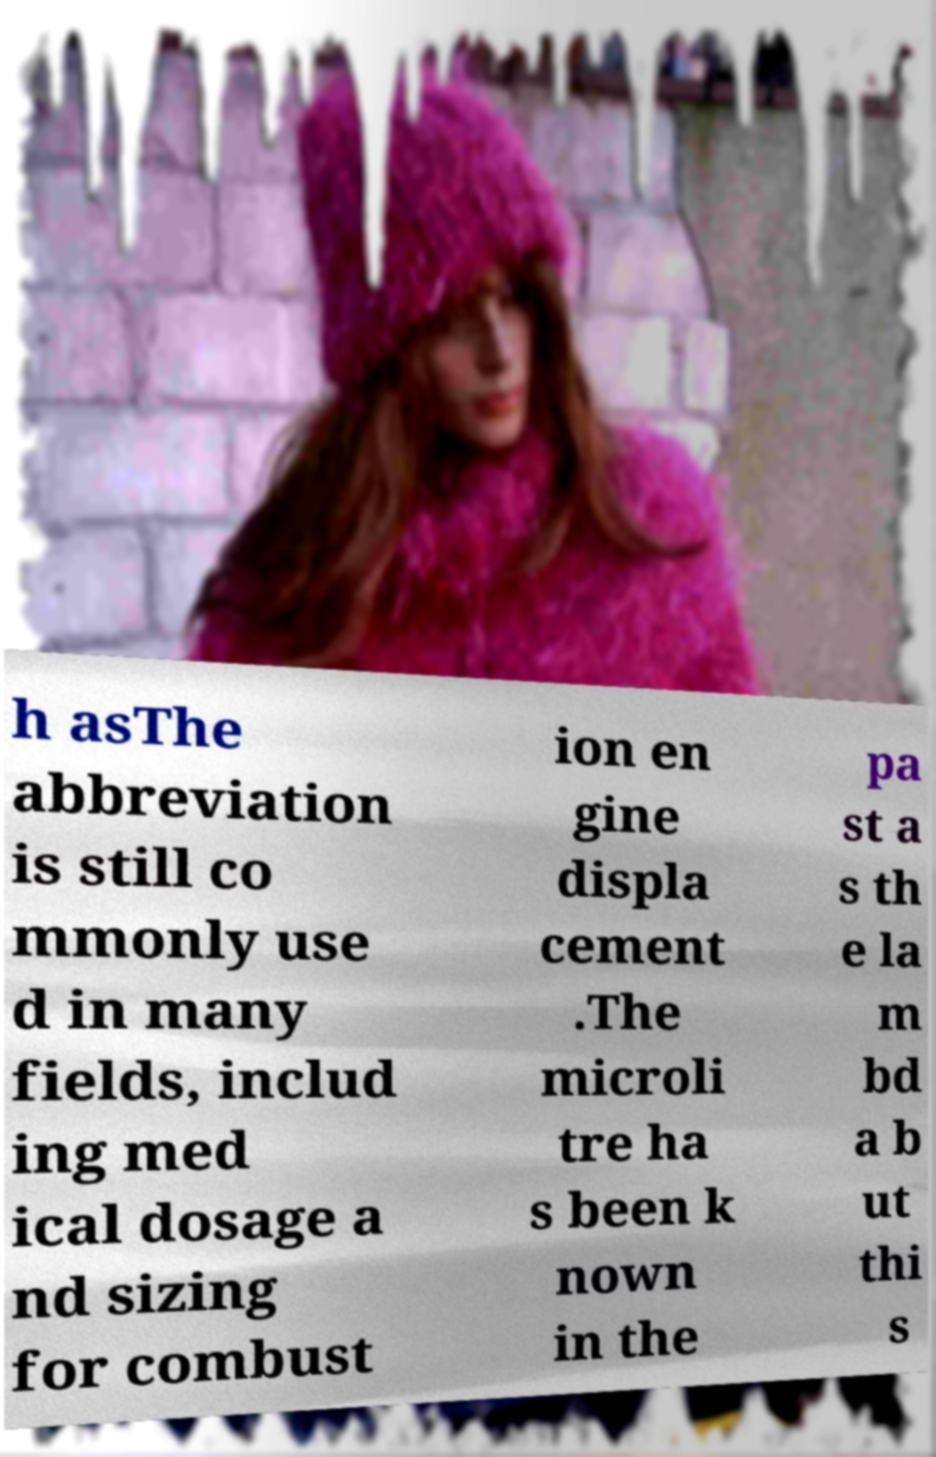Can you read and provide the text displayed in the image?This photo seems to have some interesting text. Can you extract and type it out for me? h asThe abbreviation is still co mmonly use d in many fields, includ ing med ical dosage a nd sizing for combust ion en gine displa cement .The microli tre ha s been k nown in the pa st a s th e la m bd a b ut thi s 